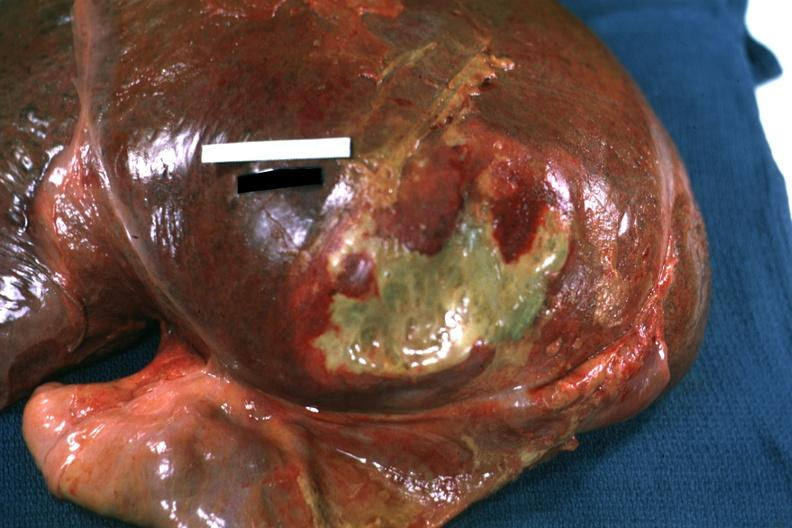what is right leaf of diaphragm reflected?
Answer the question using a single word or phrase. To show flat mass yellow green pus quite good example 